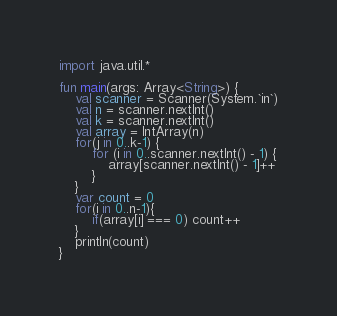<code> <loc_0><loc_0><loc_500><loc_500><_Kotlin_>import java.util.*

fun main(args: Array<String>) {
    val scanner = Scanner(System.`in`)
    val n = scanner.nextInt()
    val k = scanner.nextInt()
    val array = IntArray(n)
    for(j in 0..k-1) {
        for (i in 0..scanner.nextInt() - 1) {
            array[scanner.nextInt() - 1]++
        }
    }
    var count = 0
    for(i in 0..n-1){
        if(array[i] === 0) count++
    }
    println(count)
}</code> 